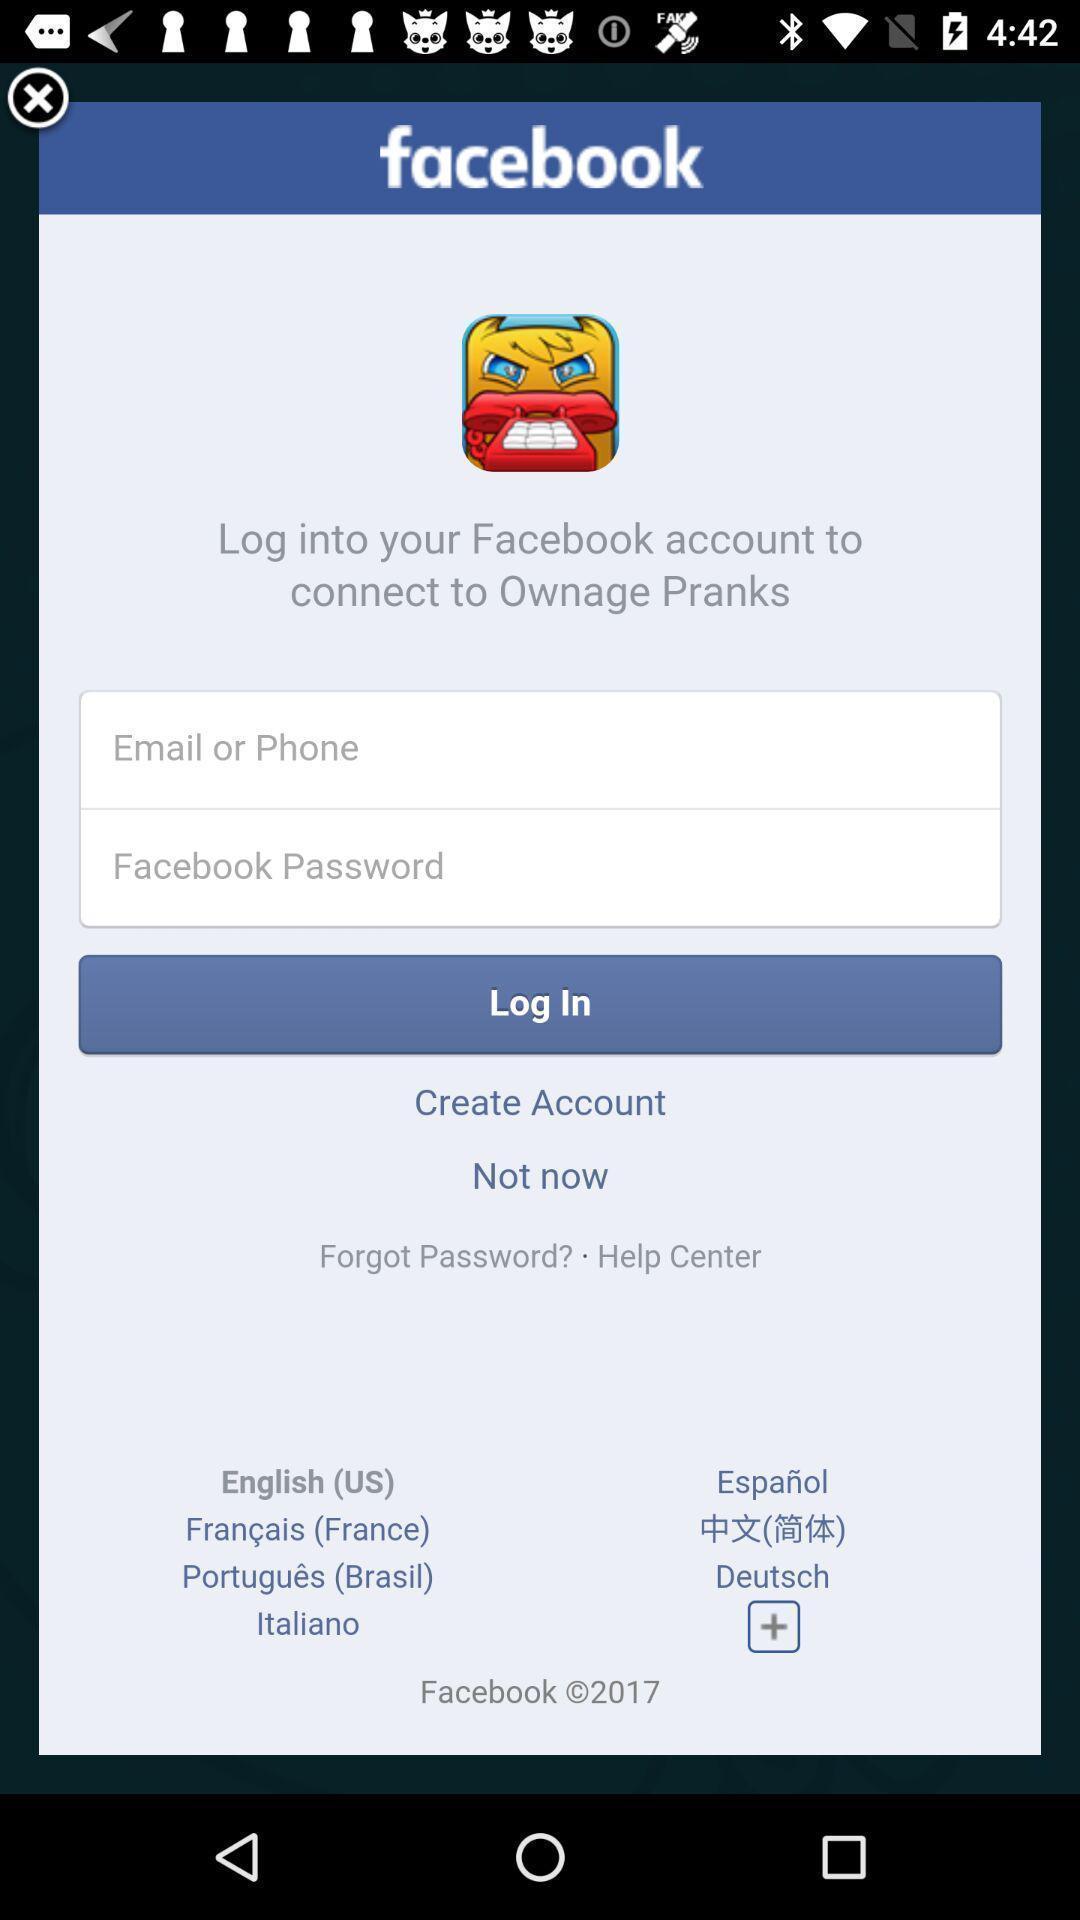Explain the elements present in this screenshot. Pop-up showing login page of a social media application. 